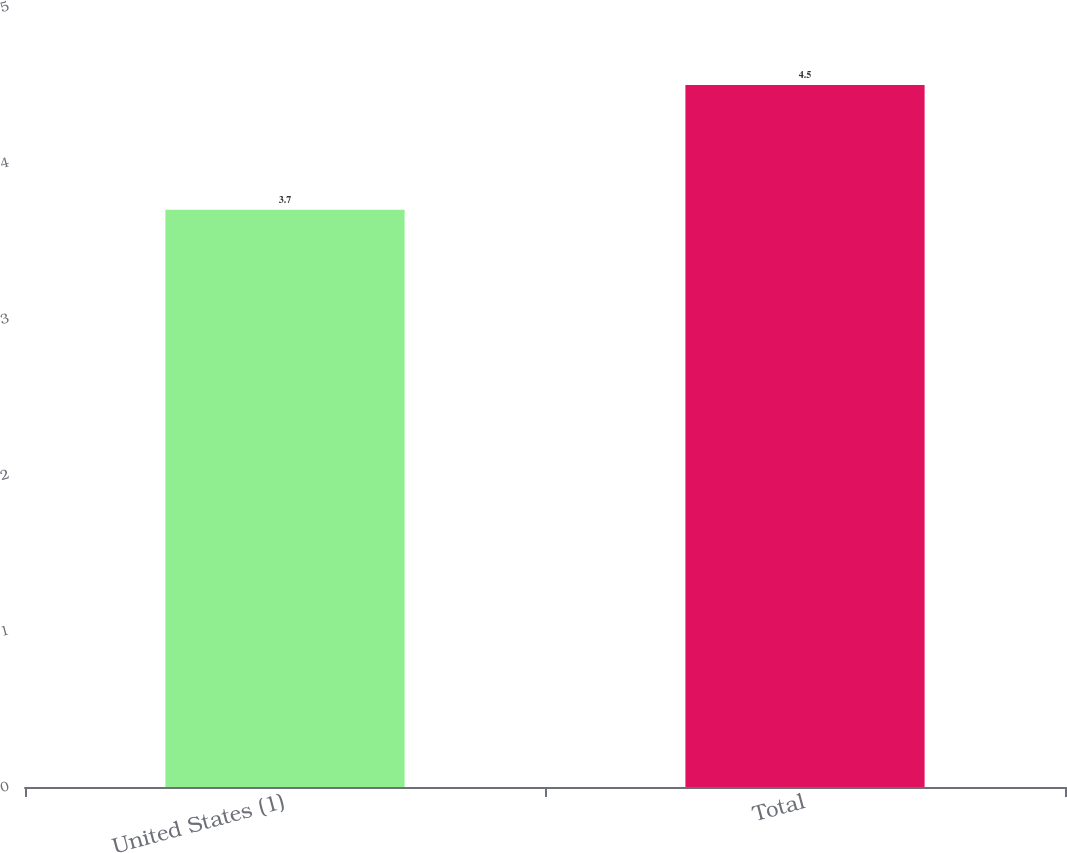Convert chart. <chart><loc_0><loc_0><loc_500><loc_500><bar_chart><fcel>United States (1)<fcel>Total<nl><fcel>3.7<fcel>4.5<nl></chart> 